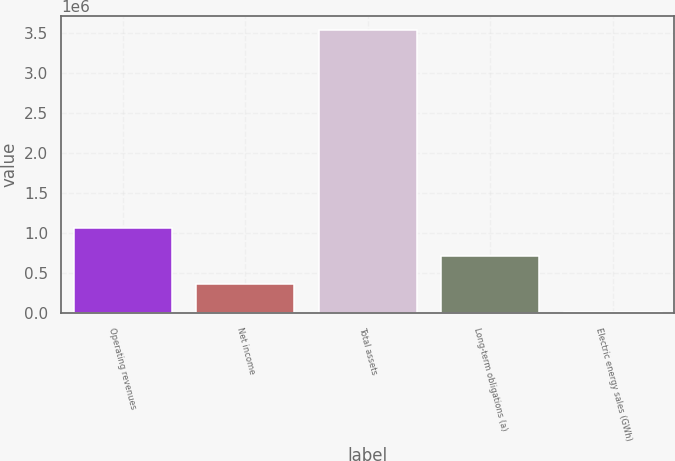Convert chart. <chart><loc_0><loc_0><loc_500><loc_500><bar_chart><fcel>Operating revenues<fcel>Net income<fcel>Total assets<fcel>Long-term obligations (a)<fcel>Electric energy sales (GWh)<nl><fcel>1.06808e+06<fcel>362556<fcel>3.53741e+06<fcel>715318<fcel>9794<nl></chart> 